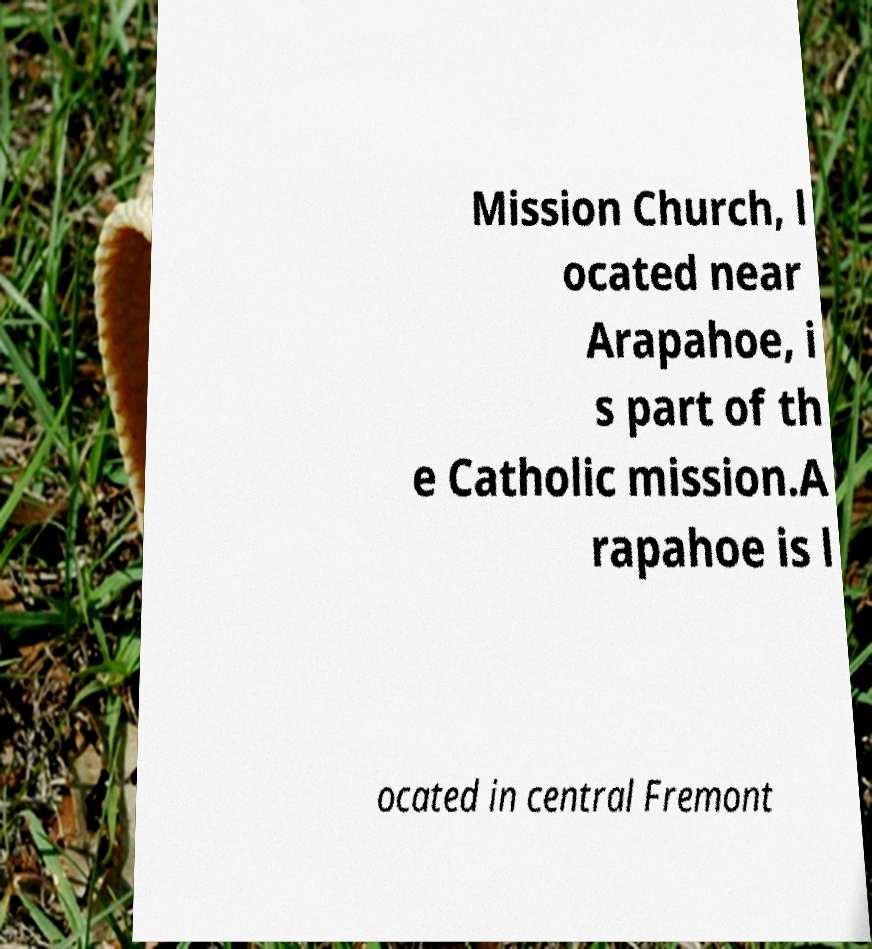What messages or text are displayed in this image? I need them in a readable, typed format. Mission Church, l ocated near Arapahoe, i s part of th e Catholic mission.A rapahoe is l ocated in central Fremont 